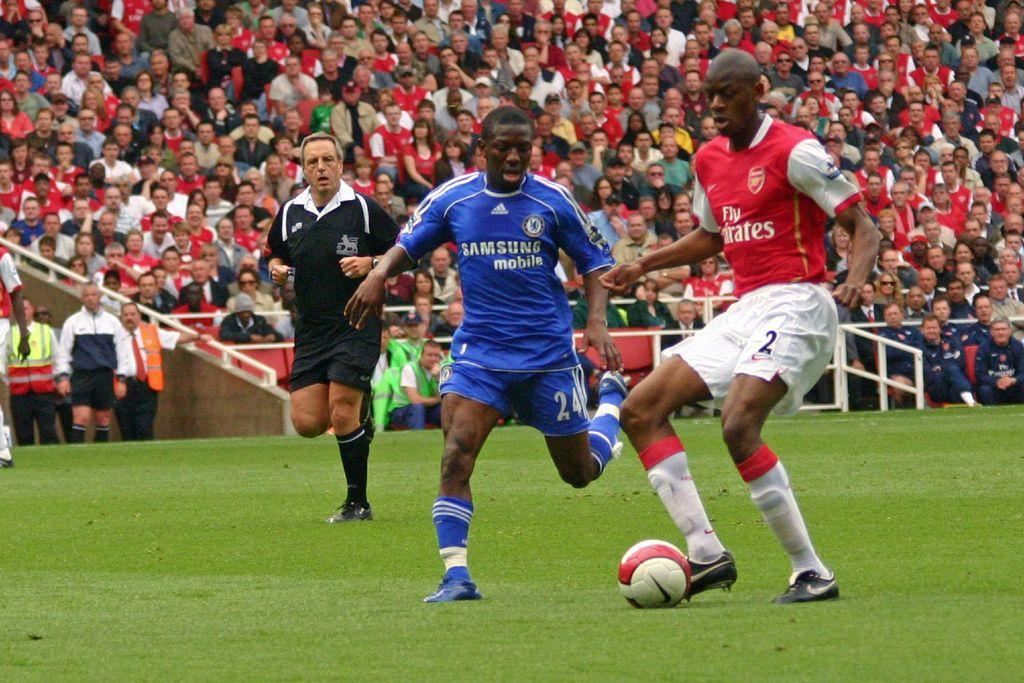<image>
Create a compact narrative representing the image presented. The soccer team wearing blue uniforms is sponsored by Samsung mobile. 